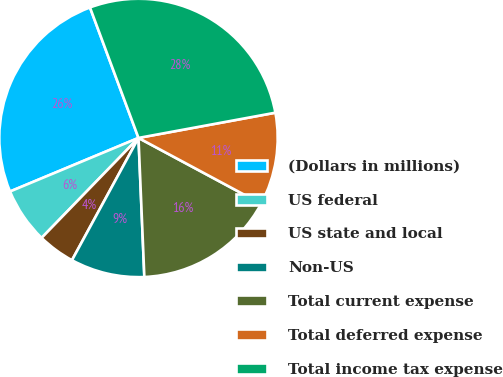Convert chart to OTSL. <chart><loc_0><loc_0><loc_500><loc_500><pie_chart><fcel>(Dollars in millions)<fcel>US federal<fcel>US state and local<fcel>Non-US<fcel>Total current expense<fcel>Total deferred expense<fcel>Total income tax expense<nl><fcel>25.62%<fcel>6.46%<fcel>4.32%<fcel>8.6%<fcel>16.49%<fcel>10.74%<fcel>27.76%<nl></chart> 